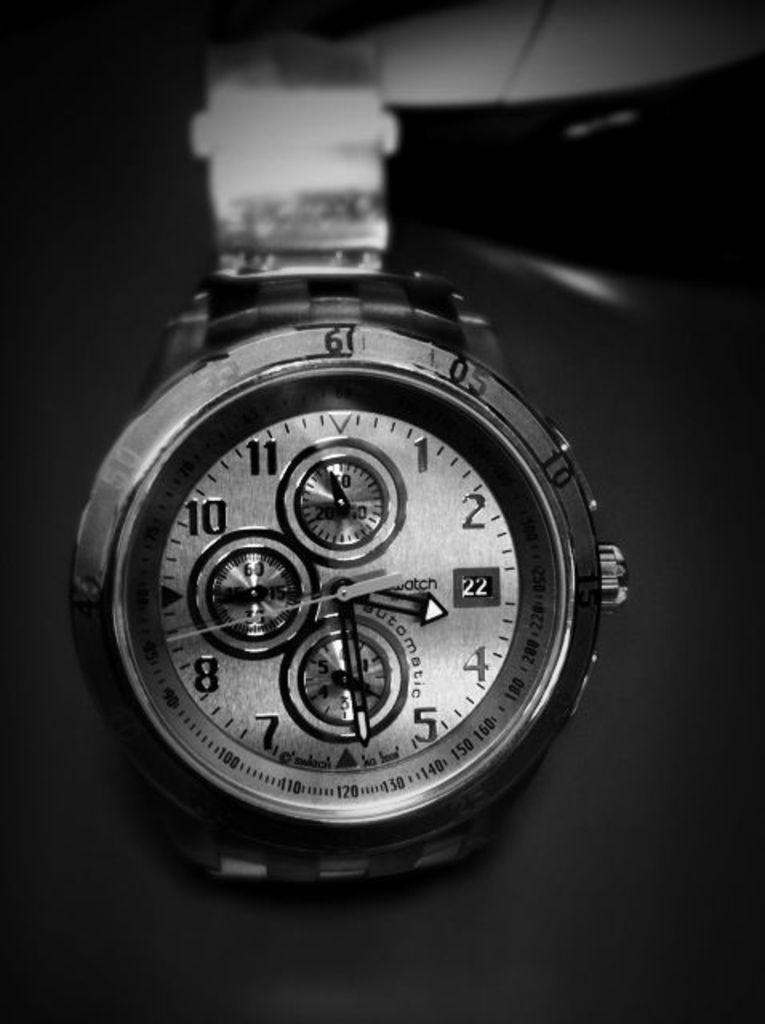<image>
Write a terse but informative summary of the picture. A watch sits against a dark background with the number 22 on it 